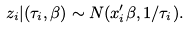Convert formula to latex. <formula><loc_0><loc_0><loc_500><loc_500>z _ { i } | ( \tau _ { i } , \beta ) \sim N ( x _ { i } ^ { \prime } \beta , 1 / \tau _ { i } ) .</formula> 